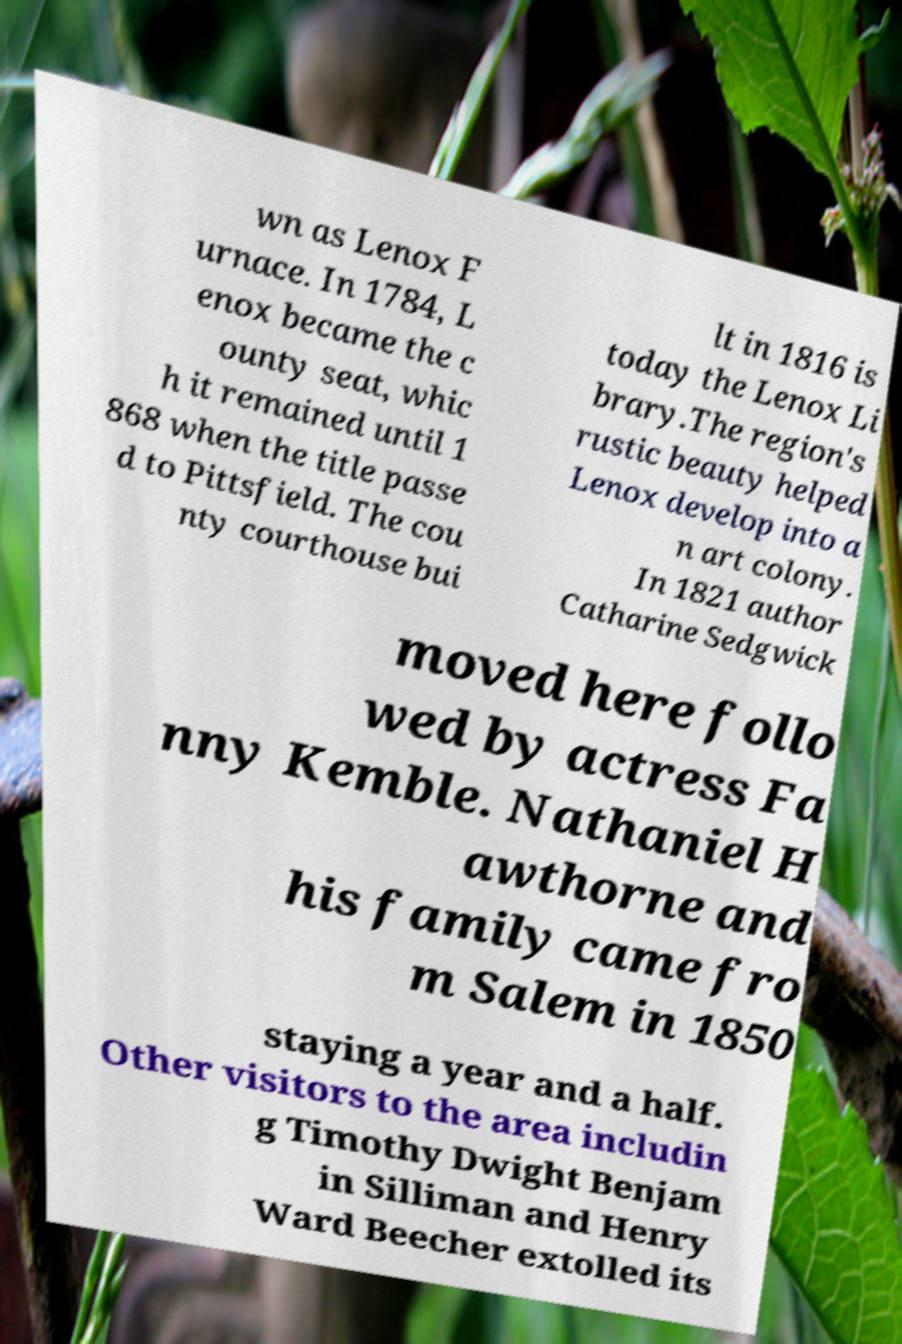I need the written content from this picture converted into text. Can you do that? wn as Lenox F urnace. In 1784, L enox became the c ounty seat, whic h it remained until 1 868 when the title passe d to Pittsfield. The cou nty courthouse bui lt in 1816 is today the Lenox Li brary.The region's rustic beauty helped Lenox develop into a n art colony. In 1821 author Catharine Sedgwick moved here follo wed by actress Fa nny Kemble. Nathaniel H awthorne and his family came fro m Salem in 1850 staying a year and a half. Other visitors to the area includin g Timothy Dwight Benjam in Silliman and Henry Ward Beecher extolled its 